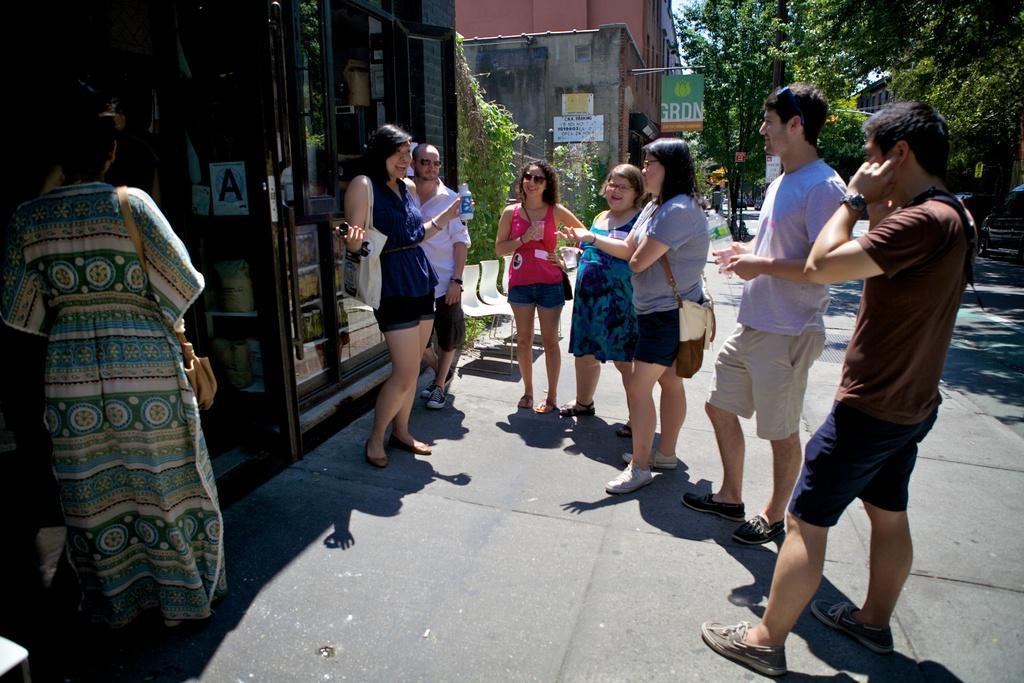Could you give a brief overview of what you see in this image? In this image I see few people who are on the path and I see that this woman and this man are holding bottles in their hands and I see that this woman is holding a glass and I can also see that these 3 are smiling. In the background I see the buildings and I see a board over here on which there is a logo and a word written and I see the road, a car over here, trees and the sky. 